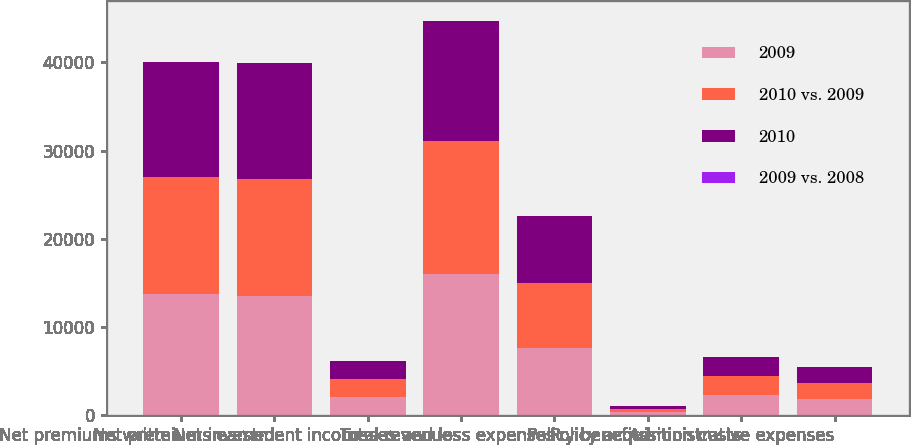Convert chart. <chart><loc_0><loc_0><loc_500><loc_500><stacked_bar_chart><ecel><fcel>Net premiums written<fcel>Net premiums earned<fcel>Net investment income<fcel>Total revenues<fcel>Losses and loss expenses<fcel>Policy benefits<fcel>Policy acquisition costs<fcel>Administrative expenses<nl><fcel>2009<fcel>13708<fcel>13504<fcel>2070<fcel>16006<fcel>7579<fcel>357<fcel>2337<fcel>1858<nl><fcel>2010 vs. 2009<fcel>13299<fcel>13240<fcel>2031<fcel>15075<fcel>7422<fcel>325<fcel>2130<fcel>1811<nl><fcel>2010<fcel>13080<fcel>13203<fcel>2062<fcel>13632<fcel>7603<fcel>399<fcel>2135<fcel>1737<nl><fcel>2009 vs. 2008<fcel>3<fcel>2<fcel>2<fcel>6<fcel>2<fcel>10<fcel>10<fcel>3<nl></chart> 